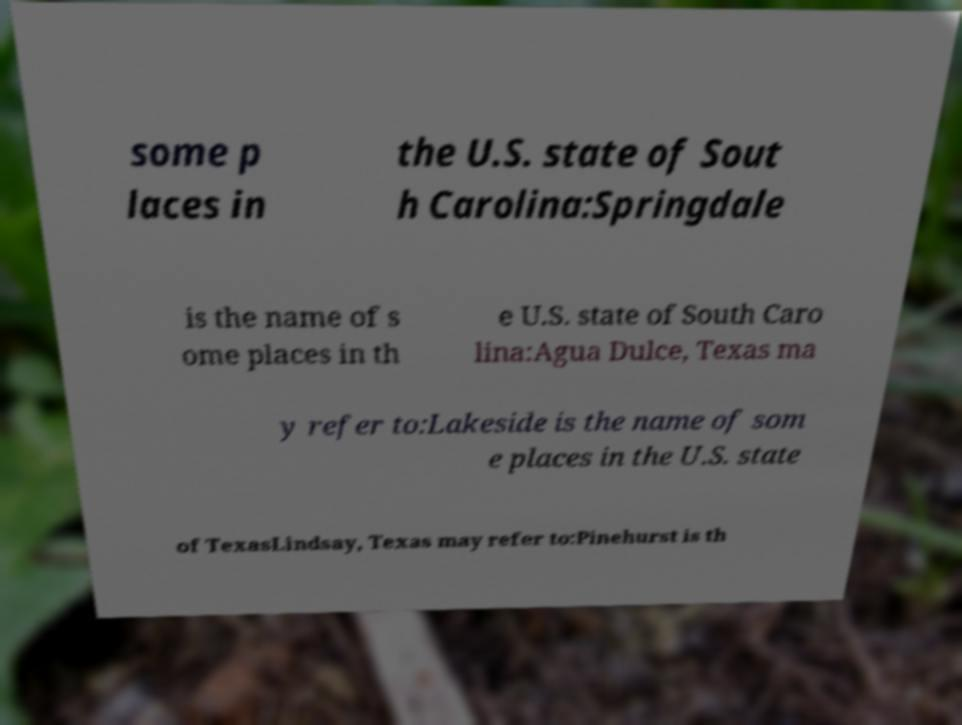There's text embedded in this image that I need extracted. Can you transcribe it verbatim? some p laces in the U.S. state of Sout h Carolina:Springdale is the name of s ome places in th e U.S. state of South Caro lina:Agua Dulce, Texas ma y refer to:Lakeside is the name of som e places in the U.S. state of TexasLindsay, Texas may refer to:Pinehurst is th 